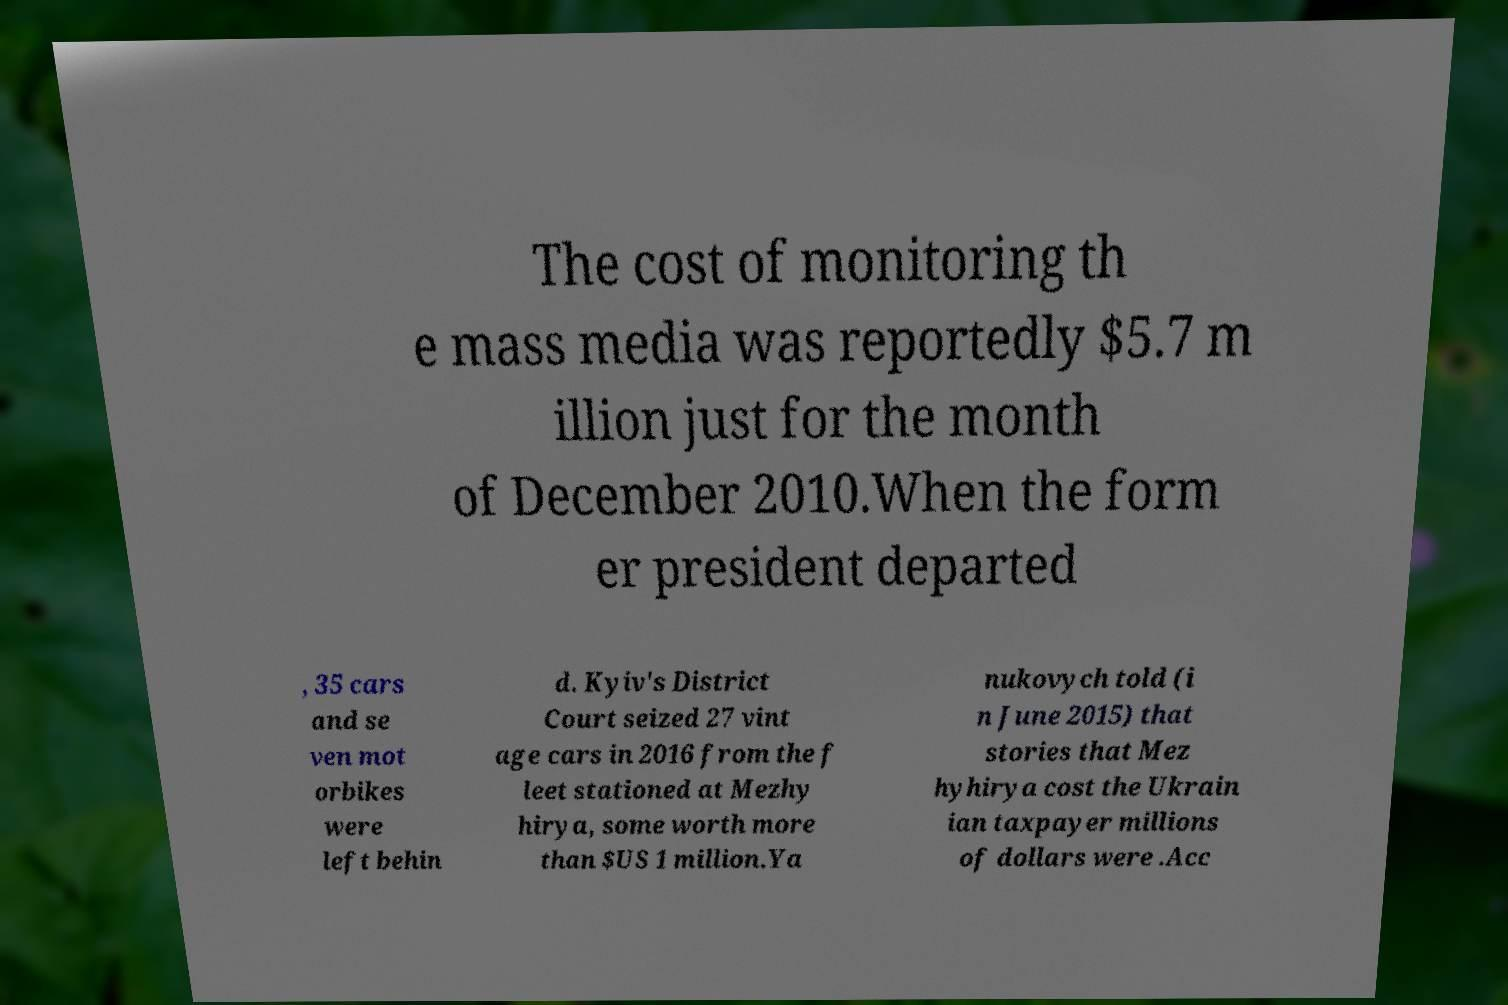Could you extract and type out the text from this image? The cost of monitoring th e mass media was reportedly $5.7 m illion just for the month of December 2010.When the form er president departed , 35 cars and se ven mot orbikes were left behin d. Kyiv's District Court seized 27 vint age cars in 2016 from the f leet stationed at Mezhy hirya, some worth more than $US 1 million.Ya nukovych told (i n June 2015) that stories that Mez hyhirya cost the Ukrain ian taxpayer millions of dollars were .Acc 